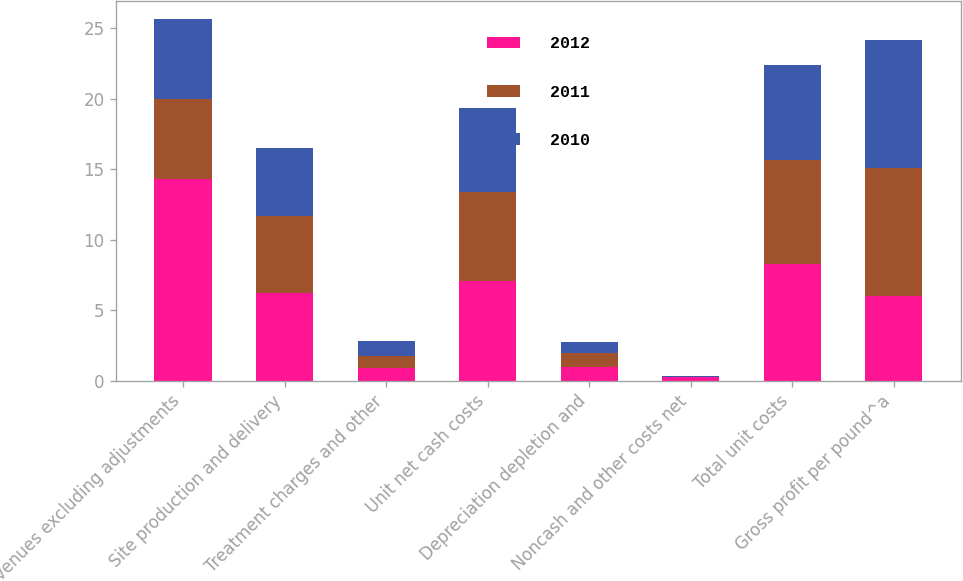<chart> <loc_0><loc_0><loc_500><loc_500><stacked_bar_chart><ecel><fcel>Revenues excluding adjustments<fcel>Site production and delivery<fcel>Treatment charges and other<fcel>Unit net cash costs<fcel>Depreciation depletion and<fcel>Noncash and other costs net<fcel>Total unit costs<fcel>Gross profit per pound^a<nl><fcel>2012<fcel>14.27<fcel>6.19<fcel>0.88<fcel>7.07<fcel>0.97<fcel>0.24<fcel>8.28<fcel>5.99<nl><fcel>2011<fcel>5.68<fcel>5.46<fcel>0.88<fcel>6.34<fcel>0.96<fcel>0.04<fcel>7.34<fcel>9.08<nl><fcel>2010<fcel>5.68<fcel>4.82<fcel>1.08<fcel>5.9<fcel>0.83<fcel>0.03<fcel>6.76<fcel>9.13<nl></chart> 